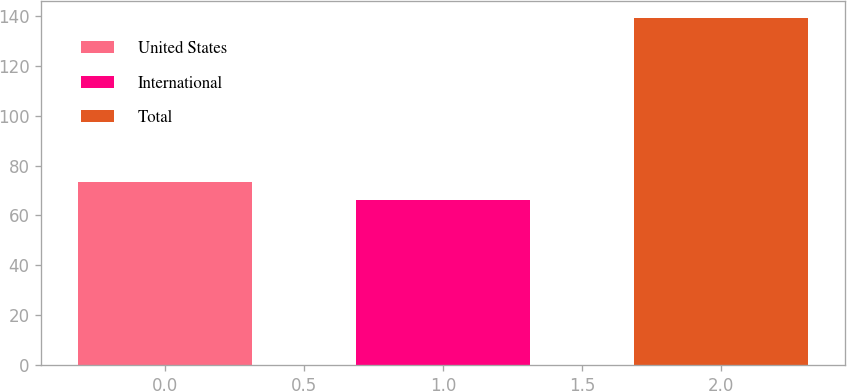<chart> <loc_0><loc_0><loc_500><loc_500><bar_chart><fcel>United States<fcel>International<fcel>Total<nl><fcel>73.3<fcel>66<fcel>139<nl></chart> 